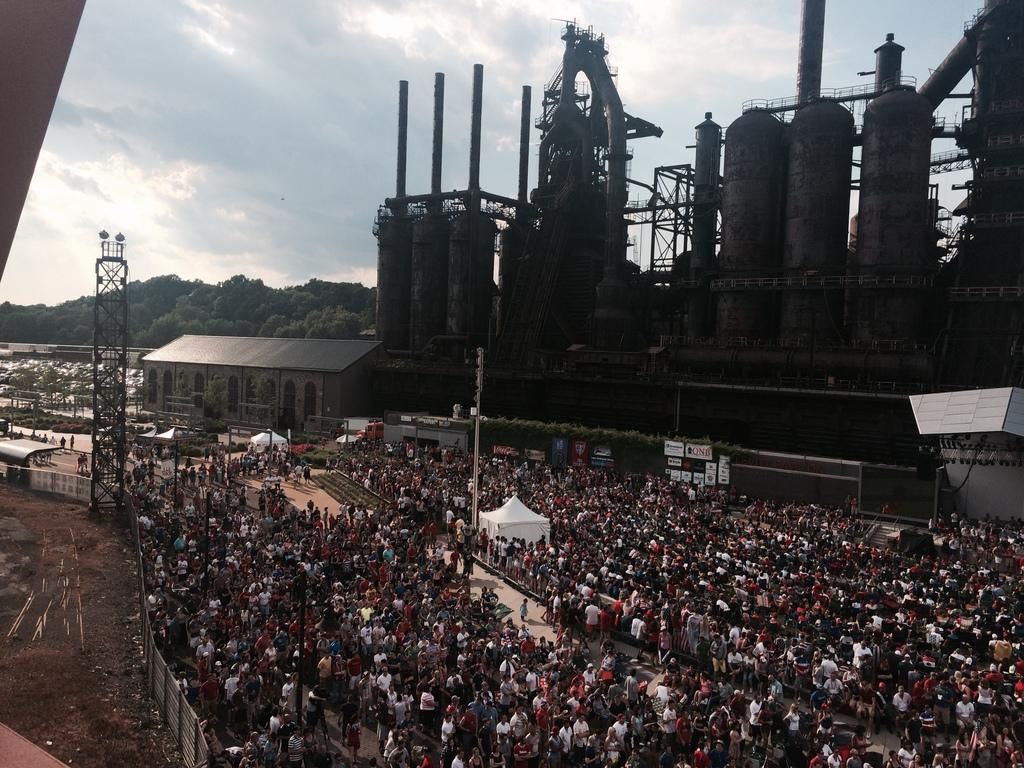What is happening on the road in the image? There is a crowd standing on the road in the image. What can be seen in the background of the image? The sky with clouds, towers, buildings, trees, motor vehicles, and tents are visible in the background. Can you describe the sky in the image? The sky in the image has clouds visible. What else is present in the background of the image? Factory equipment is visible in the background. What type of bread can be seen in the image? There is no bread present in the image. Can you describe the sand in the image? There is no sand present in the image. 